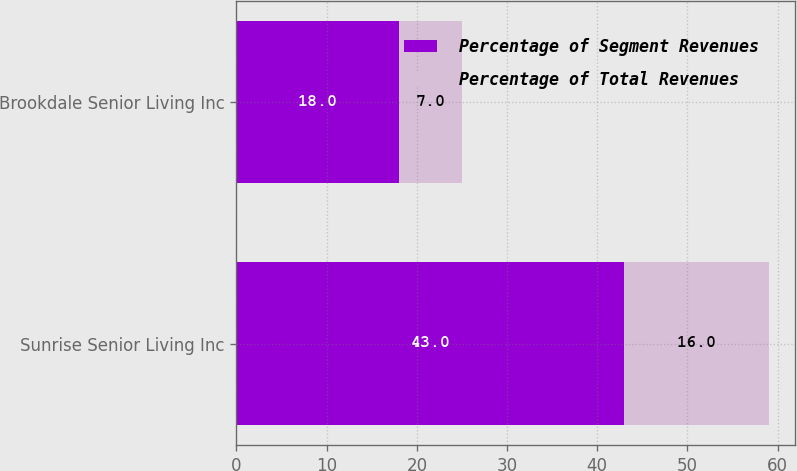<chart> <loc_0><loc_0><loc_500><loc_500><stacked_bar_chart><ecel><fcel>Sunrise Senior Living Inc<fcel>Brookdale Senior Living Inc<nl><fcel>Percentage of Segment Revenues<fcel>43<fcel>18<nl><fcel>Percentage of Total Revenues<fcel>16<fcel>7<nl></chart> 